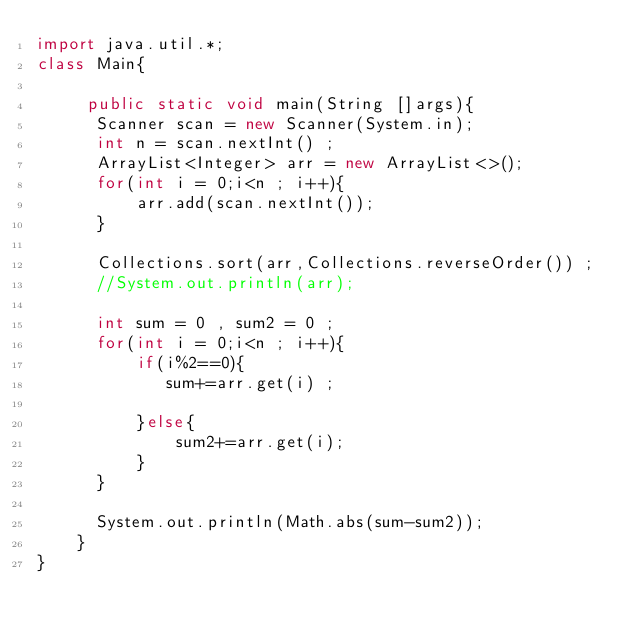<code> <loc_0><loc_0><loc_500><loc_500><_Java_>import java.util.*;
class Main{

     public static void main(String []args){
      Scanner scan = new Scanner(System.in);
      int n = scan.nextInt() ;
      ArrayList<Integer> arr = new ArrayList<>();
      for(int i = 0;i<n ; i++){
          arr.add(scan.nextInt());
      }
      
      Collections.sort(arr,Collections.reverseOrder()) ;
      //System.out.println(arr);
      
      int sum = 0 , sum2 = 0 ;
      for(int i = 0;i<n ; i++){
          if(i%2==0){
             sum+=arr.get(i) ;
              
          }else{
              sum2+=arr.get(i);
          }
      }
      
      System.out.println(Math.abs(sum-sum2));
    }
}</code> 